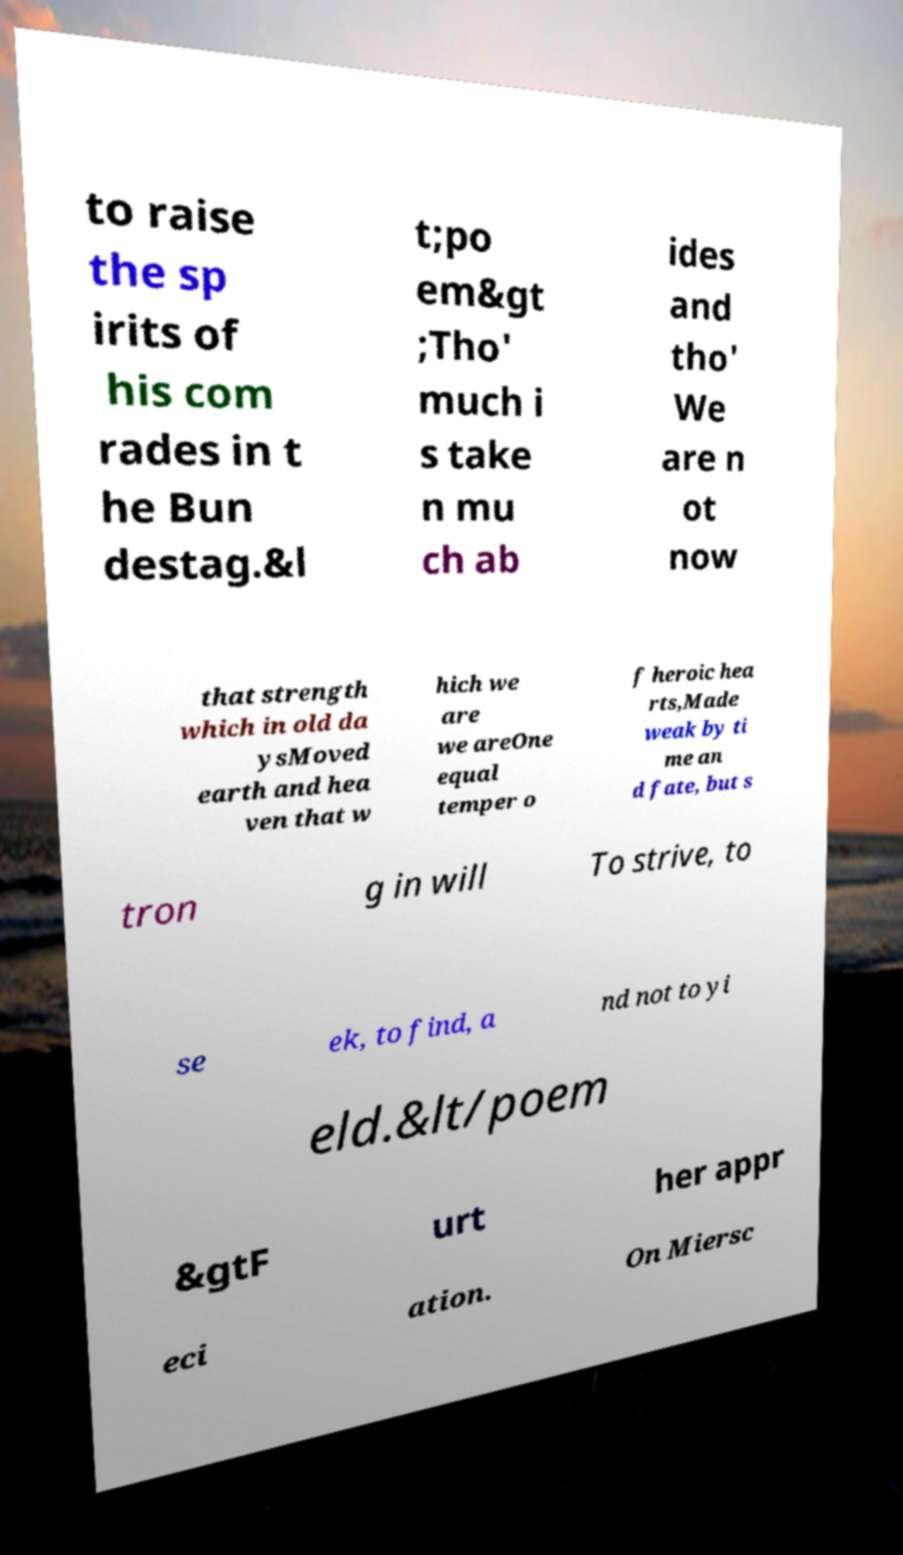What messages or text are displayed in this image? I need them in a readable, typed format. to raise the sp irits of his com rades in t he Bun destag.&l t;po em&gt ;Tho' much i s take n mu ch ab ides and tho' We are n ot now that strength which in old da ysMoved earth and hea ven that w hich we are we areOne equal temper o f heroic hea rts,Made weak by ti me an d fate, but s tron g in will To strive, to se ek, to find, a nd not to yi eld.&lt/poem &gtF urt her appr eci ation. On Miersc 